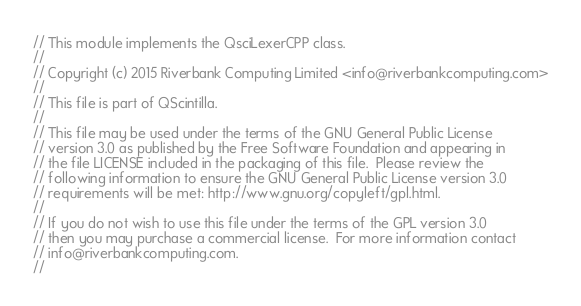Convert code to text. <code><loc_0><loc_0><loc_500><loc_500><_C++_>// This module implements the QsciLexerCPP class.
//
// Copyright (c) 2015 Riverbank Computing Limited <info@riverbankcomputing.com>
// 
// This file is part of QScintilla.
// 
// This file may be used under the terms of the GNU General Public License
// version 3.0 as published by the Free Software Foundation and appearing in
// the file LICENSE included in the packaging of this file.  Please review the
// following information to ensure the GNU General Public License version 3.0
// requirements will be met: http://www.gnu.org/copyleft/gpl.html.
// 
// If you do not wish to use this file under the terms of the GPL version 3.0
// then you may purchase a commercial license.  For more information contact
// info@riverbankcomputing.com.
// </code> 